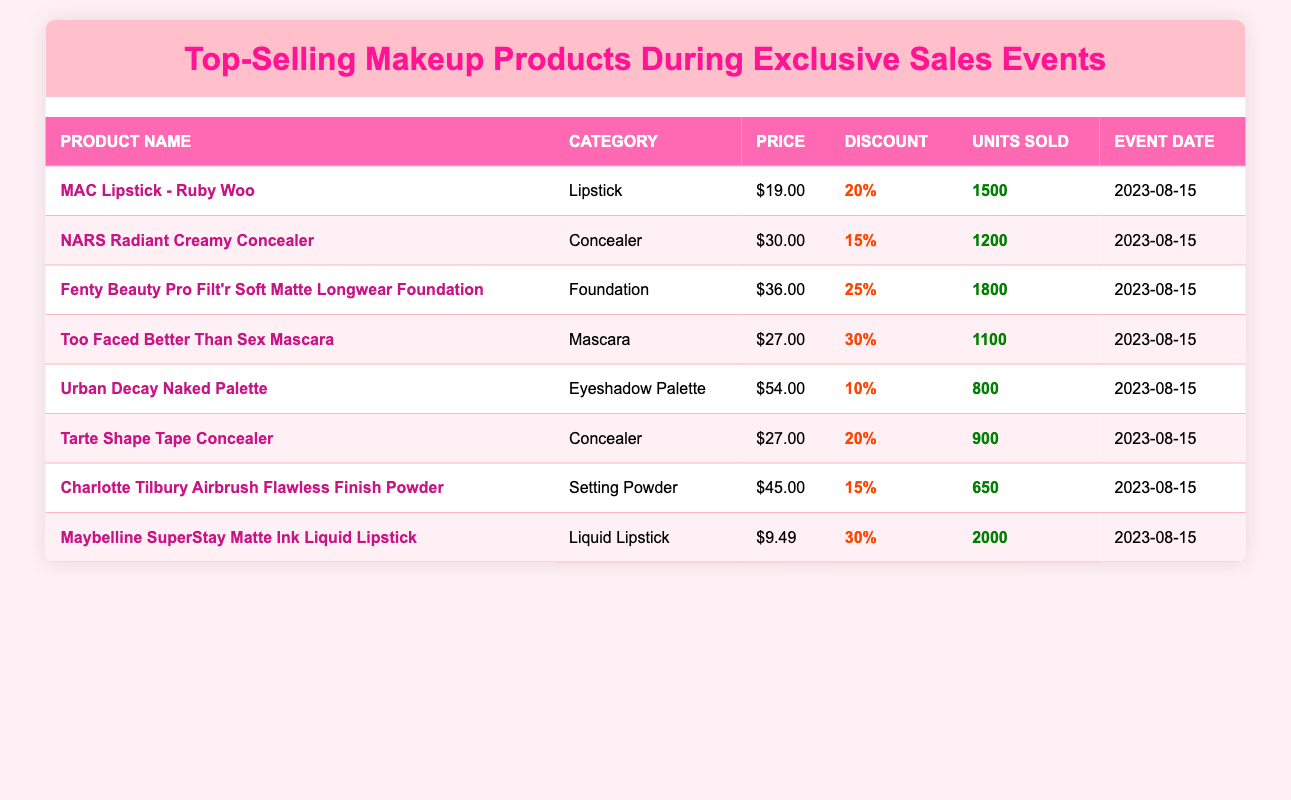What was the total number of units sold for the MAC Lipstick - Ruby Woo? The table indicates that 1500 units of MAC Lipstick - Ruby Woo were sold during the event.
Answer: 1500 Which product had the highest discount percentage? Comparing the discount percentages in the table, Fenty Beauty Pro Filt'r Soft Matte Longwear Foundation has the highest discount at 25%.
Answer: Fenty Beauty Pro Filt'r Soft Matte Longwear Foundation How many units of Maybelline SuperStay Matte Ink Liquid Lipstick were sold? The table shows that 2000 units of Maybelline SuperStay Matte Ink Liquid Lipstick were sold during the event.
Answer: 2000 What is the average price of the top-selling products? The prices of the products are $19.00, $30.00, $36.00, $27.00, $54.00, $27.00, $45.00, and $9.49. First, sum them up: 19 + 30 + 36 + 27 + 54 + 27 + 45 + 9.49 = 247.49. There are 8 products, so the average price is 247.49 / 8 = 30.93625, which rounds to $30.94.
Answer: $30.94 Which category sold the most units? The units sold for each category are: Lipstick (1500), Concealer (1200 + 900), Foundation (1800), Mascara (1100), Eyeshadow Palette (800), and Setting Powder (650). The total for Concealers is 2100, which is more than any other category.
Answer: Concealer Was the event date for all these products the same? All the products listed in the table were sold during the same event date, which is 2023-08-15.
Answer: Yes What is the difference in units sold between the best-selling and worst-selling product? Maybelline SuperStay Matte Ink Liquid Lipstick sold 2000 units, while Urban Decay Naked Palette sold 800 units. The difference is 2000 - 800 = 1200.
Answer: 1200 Does any product belong to the category of Setting Powder? Yes, Charlotte Tilbury Airbrush Flawless Finish Powder is the product listed under the category of Setting Powder.
Answer: Yes Which product sold the least units, and how many were sold? The product that sold the least was Charlotte Tilbury Airbrush Flawless Finish Powder, which sold 650 units.
Answer: 650 What percentage of total units sold during the event does Maybelline SuperStay Matte Ink Liquid Lipstick represent? The total units sold across all products is 1500 + 1200 + 1800 + 1100 + 800 + 900 + 650 + 2000 = 9150. Maybelline SuperStay sold 2000 units, so the percentage is (2000 / 9150) * 100 = 21.8344%, which rounds to about 21.83%.
Answer: 21.83% 